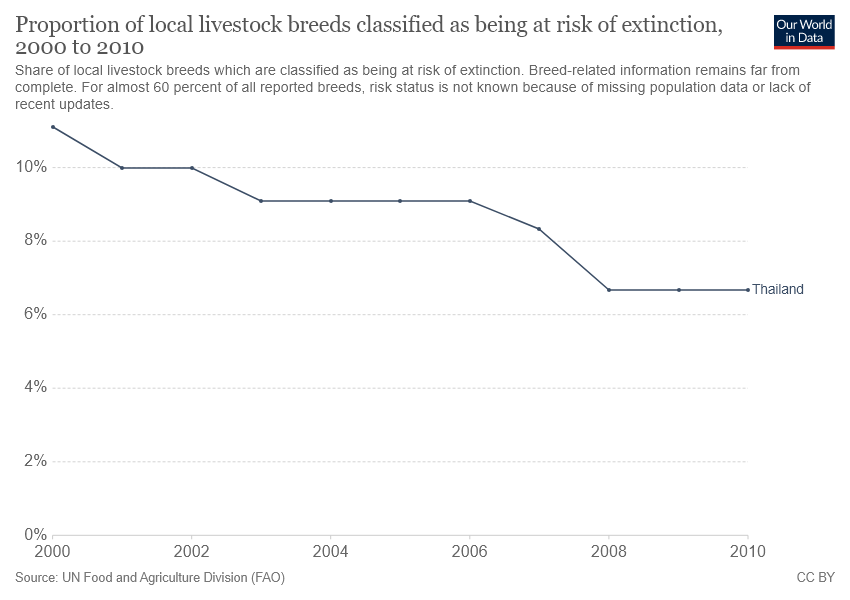Draw attention to some important aspects in this diagram. In 2002 and 2003, the percentage of livestock breeds classified as at risk of extinction differed by 0.01%. In 2000, the year with the highest point on the graph was recorded. 